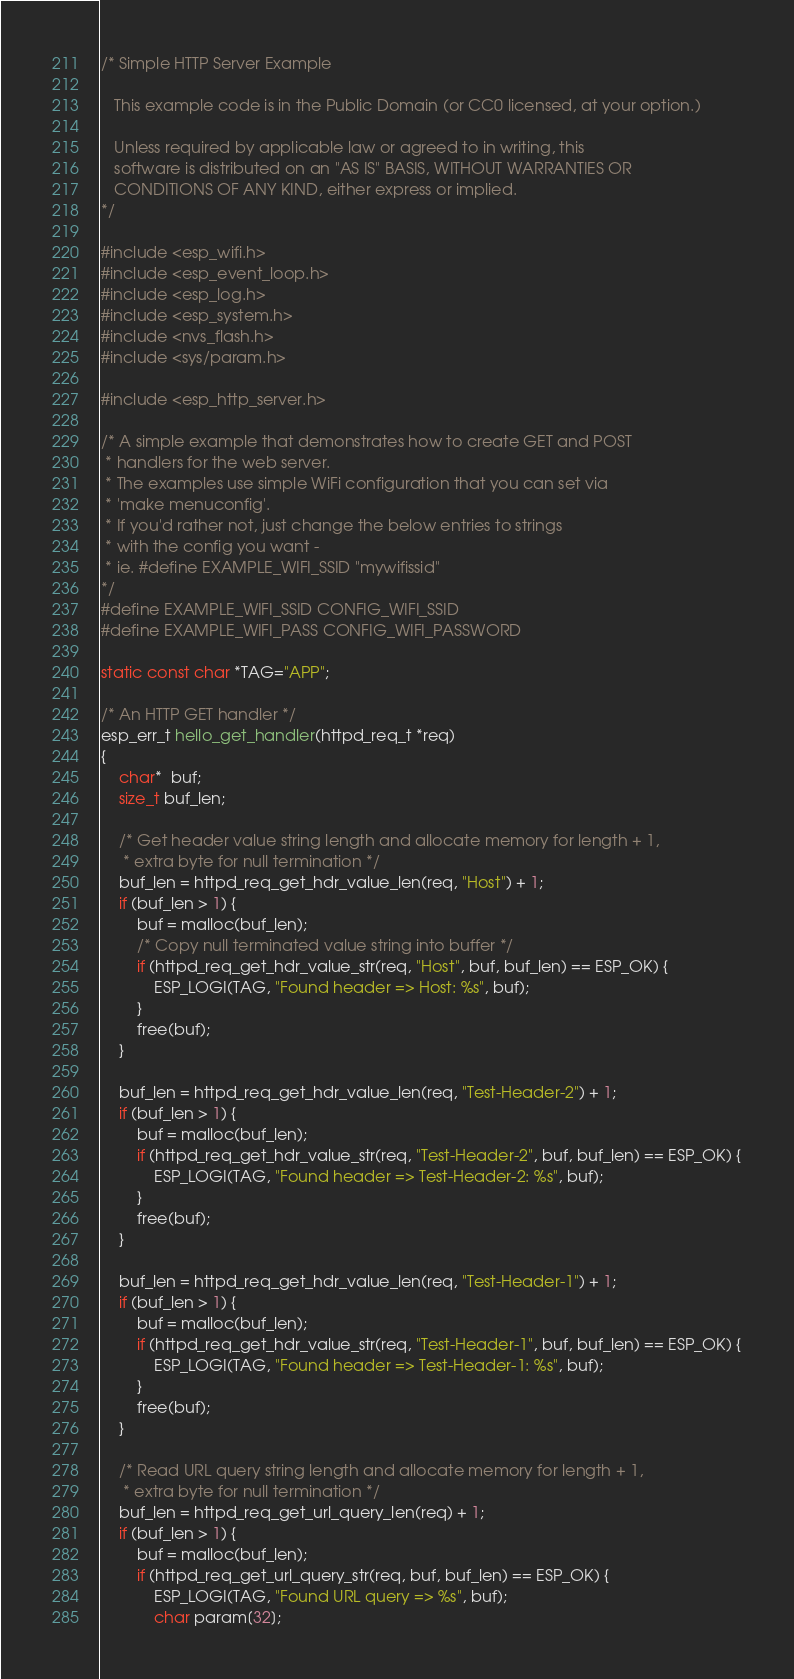<code> <loc_0><loc_0><loc_500><loc_500><_C_>/* Simple HTTP Server Example

   This example code is in the Public Domain (or CC0 licensed, at your option.)

   Unless required by applicable law or agreed to in writing, this
   software is distributed on an "AS IS" BASIS, WITHOUT WARRANTIES OR
   CONDITIONS OF ANY KIND, either express or implied.
*/

#include <esp_wifi.h>
#include <esp_event_loop.h>
#include <esp_log.h>
#include <esp_system.h>
#include <nvs_flash.h>
#include <sys/param.h>

#include <esp_http_server.h>

/* A simple example that demonstrates how to create GET and POST
 * handlers for the web server.
 * The examples use simple WiFi configuration that you can set via
 * 'make menuconfig'.
 * If you'd rather not, just change the below entries to strings
 * with the config you want -
 * ie. #define EXAMPLE_WIFI_SSID "mywifissid"
*/
#define EXAMPLE_WIFI_SSID CONFIG_WIFI_SSID
#define EXAMPLE_WIFI_PASS CONFIG_WIFI_PASSWORD

static const char *TAG="APP";

/* An HTTP GET handler */
esp_err_t hello_get_handler(httpd_req_t *req)
{
    char*  buf;
    size_t buf_len;

    /* Get header value string length and allocate memory for length + 1,
     * extra byte for null termination */
    buf_len = httpd_req_get_hdr_value_len(req, "Host") + 1;
    if (buf_len > 1) {
        buf = malloc(buf_len);
        /* Copy null terminated value string into buffer */
        if (httpd_req_get_hdr_value_str(req, "Host", buf, buf_len) == ESP_OK) {
            ESP_LOGI(TAG, "Found header => Host: %s", buf);
        }
        free(buf);
    }

    buf_len = httpd_req_get_hdr_value_len(req, "Test-Header-2") + 1;
    if (buf_len > 1) {
        buf = malloc(buf_len);
        if (httpd_req_get_hdr_value_str(req, "Test-Header-2", buf, buf_len) == ESP_OK) {
            ESP_LOGI(TAG, "Found header => Test-Header-2: %s", buf);
        }
        free(buf);
    }

    buf_len = httpd_req_get_hdr_value_len(req, "Test-Header-1") + 1;
    if (buf_len > 1) {
        buf = malloc(buf_len);
        if (httpd_req_get_hdr_value_str(req, "Test-Header-1", buf, buf_len) == ESP_OK) {
            ESP_LOGI(TAG, "Found header => Test-Header-1: %s", buf);
        }
        free(buf);
    }

    /* Read URL query string length and allocate memory for length + 1,
     * extra byte for null termination */
    buf_len = httpd_req_get_url_query_len(req) + 1;
    if (buf_len > 1) {
        buf = malloc(buf_len);
        if (httpd_req_get_url_query_str(req, buf, buf_len) == ESP_OK) {
            ESP_LOGI(TAG, "Found URL query => %s", buf);
            char param[32];</code> 